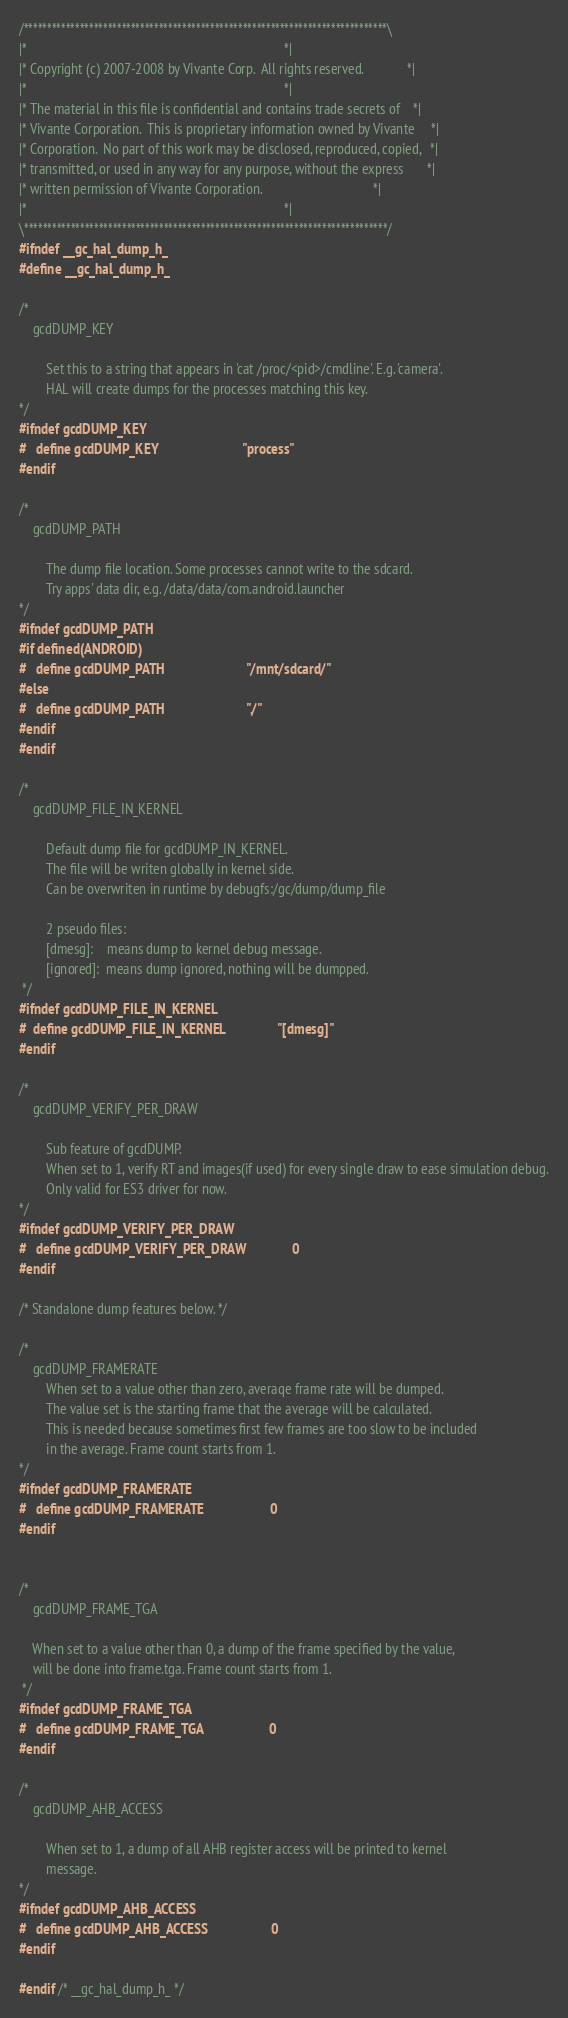<code> <loc_0><loc_0><loc_500><loc_500><_C_>/******************************************************************************\
|*                                                                            *|
|* Copyright (c) 2007-2008 by Vivante Corp.  All rights reserved.             *|
|*                                                                            *|
|* The material in this file is confidential and contains trade secrets of    *|
|* Vivante Corporation.  This is proprietary information owned by Vivante     *|
|* Corporation.  No part of this work may be disclosed, reproduced, copied,   *|
|* transmitted, or used in any way for any purpose, without the express       *|
|* written permission of Vivante Corporation.                                 *|
|*                                                                            *|
\******************************************************************************/
#ifndef __gc_hal_dump_h_
#define __gc_hal_dump_h_

/*
    gcdDUMP_KEY

        Set this to a string that appears in 'cat /proc/<pid>/cmdline'. E.g. 'camera'.
        HAL will create dumps for the processes matching this key.
*/
#ifndef gcdDUMP_KEY
#   define gcdDUMP_KEY                          "process"
#endif

/*
    gcdDUMP_PATH

        The dump file location. Some processes cannot write to the sdcard.
        Try apps' data dir, e.g. /data/data/com.android.launcher
*/
#ifndef gcdDUMP_PATH
#if defined(ANDROID)
#   define gcdDUMP_PATH                         "/mnt/sdcard/"
#else
#   define gcdDUMP_PATH                         "./"
#endif
#endif

/*
    gcdDUMP_FILE_IN_KERNEL

        Default dump file for gcdDUMP_IN_KERNEL.
        The file will be writen globally in kernel side.
        Can be overwriten in runtime by debugfs:/gc/dump/dump_file

        2 pseudo files:
        [dmesg]:    means dump to kernel debug message.
        [ignored]:  means dump ignored, nothing will be dumpped.
 */
#ifndef gcdDUMP_FILE_IN_KERNEL
#  define gcdDUMP_FILE_IN_KERNEL                "[dmesg]"
#endif

/*
    gcdDUMP_VERIFY_PER_DRAW

        Sub feature of gcdDUMP.
        When set to 1, verify RT and images(if used) for every single draw to ease simulation debug.
        Only valid for ES3 driver for now.
*/
#ifndef gcdDUMP_VERIFY_PER_DRAW
#   define gcdDUMP_VERIFY_PER_DRAW              0
#endif

/* Standalone dump features below. */

/*
    gcdDUMP_FRAMERATE
        When set to a value other than zero, averaqe frame rate will be dumped.
        The value set is the starting frame that the average will be calculated.
        This is needed because sometimes first few frames are too slow to be included
        in the average. Frame count starts from 1.
*/
#ifndef gcdDUMP_FRAMERATE
#   define gcdDUMP_FRAMERATE                    0
#endif


/*
    gcdDUMP_FRAME_TGA

    When set to a value other than 0, a dump of the frame specified by the value,
    will be done into frame.tga. Frame count starts from 1.
 */
#ifndef gcdDUMP_FRAME_TGA
#   define gcdDUMP_FRAME_TGA                    0
#endif

/*
    gcdDUMP_AHB_ACCESS

        When set to 1, a dump of all AHB register access will be printed to kernel
        message.
*/
#ifndef gcdDUMP_AHB_ACCESS
#   define gcdDUMP_AHB_ACCESS                   0
#endif

#endif /* __gc_hal_dump_h_ */

</code> 